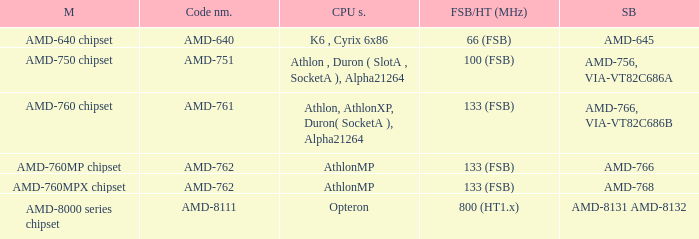What is the code name when the Southbridge shows as amd-766, via-vt82c686b? AMD-761. 